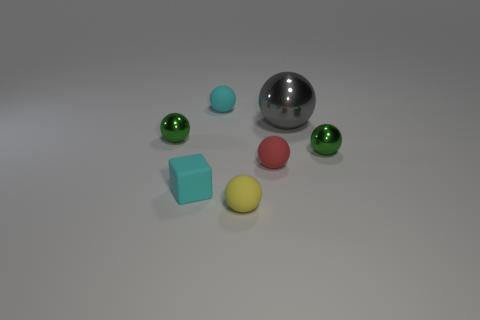What is the size of the gray shiny object that is the same shape as the yellow matte object?
Your answer should be very brief. Large. Is there anything else that is the same size as the gray metallic thing?
Keep it short and to the point. No. What is the size of the yellow object?
Your answer should be compact. Small. What material is the green ball behind the green thing that is right of the tiny metallic object to the left of the red ball made of?
Your answer should be very brief. Metal. How many other objects are there of the same color as the tiny block?
Your answer should be very brief. 1. What number of cyan things are either small rubber blocks or tiny metal spheres?
Your answer should be very brief. 1. There is a red thing to the right of the small cyan block; what is its material?
Ensure brevity in your answer.  Rubber. Are the small green ball on the right side of the red matte sphere and the large gray ball made of the same material?
Your response must be concise. Yes. How many small green objects are behind the green object to the right of the gray metallic ball on the right side of the yellow matte thing?
Ensure brevity in your answer.  1. What number of other objects are the same material as the large gray sphere?
Your response must be concise. 2. 